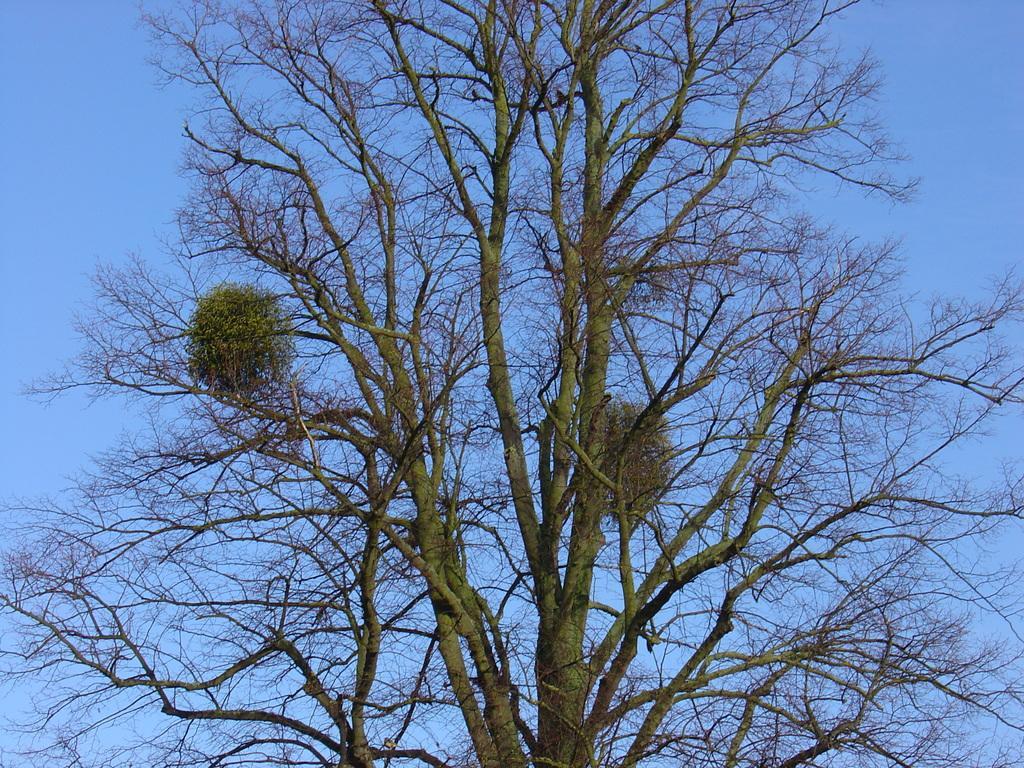Please provide a concise description of this image. In this image we can see a dried tree and sky. 